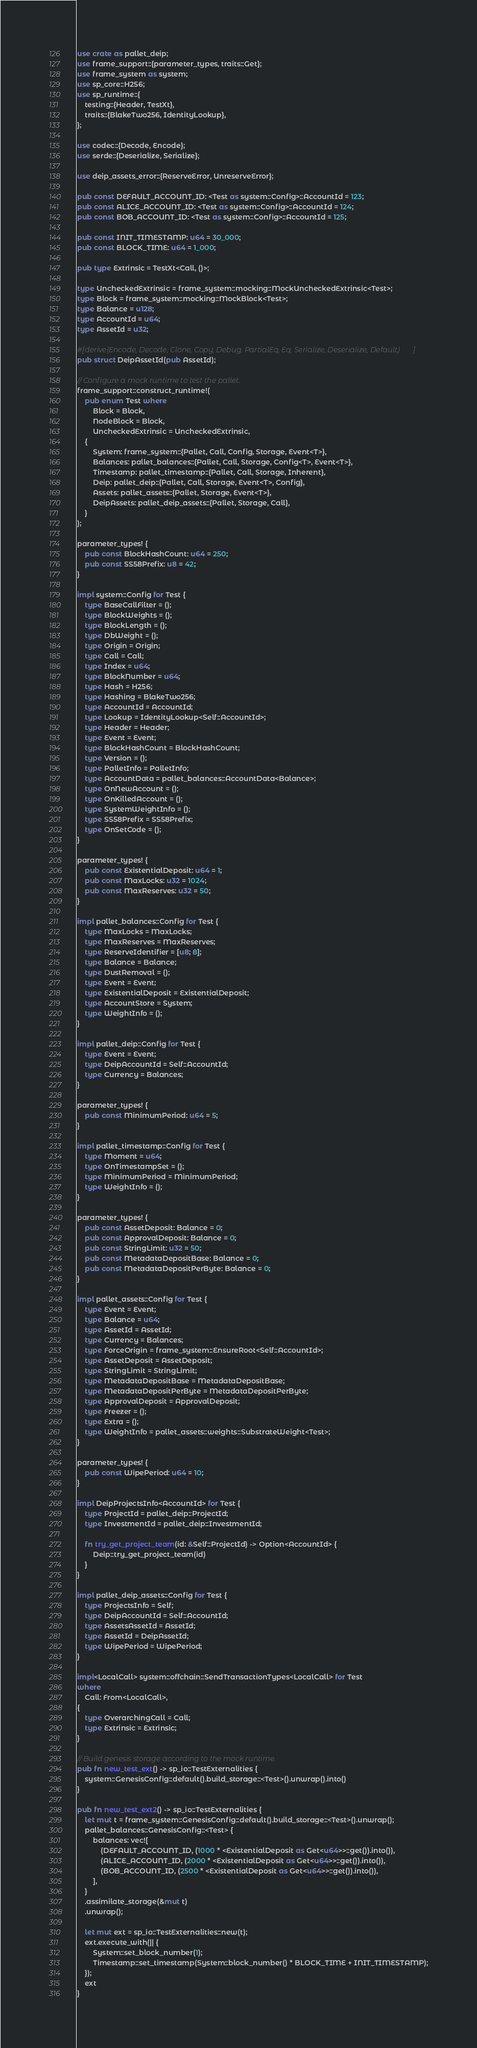Convert code to text. <code><loc_0><loc_0><loc_500><loc_500><_Rust_>use crate as pallet_deip;
use frame_support::{parameter_types, traits::Get};
use frame_system as system;
use sp_core::H256;
use sp_runtime::{
    testing::{Header, TestXt},
    traits::{BlakeTwo256, IdentityLookup},
};

use codec::{Decode, Encode};
use serde::{Deserialize, Serialize};

use deip_assets_error::{ReserveError, UnreserveError};

pub const DEFAULT_ACCOUNT_ID: <Test as system::Config>::AccountId = 123;
pub const ALICE_ACCOUNT_ID: <Test as system::Config>::AccountId = 124;
pub const BOB_ACCOUNT_ID: <Test as system::Config>::AccountId = 125;

pub const INIT_TIMESTAMP: u64 = 30_000;
pub const BLOCK_TIME: u64 = 1_000;

pub type Extrinsic = TestXt<Call, ()>;

type UncheckedExtrinsic = frame_system::mocking::MockUncheckedExtrinsic<Test>;
type Block = frame_system::mocking::MockBlock<Test>;
type Balance = u128;
type AccountId = u64;
type AssetId = u32;

#[derive(Encode, Decode, Clone, Copy, Debug, PartialEq, Eq, Serialize, Deserialize, Default)]
pub struct DeipAssetId(pub AssetId);

// Configure a mock runtime to test the pallet.
frame_support::construct_runtime!(
    pub enum Test where
        Block = Block,
        NodeBlock = Block,
        UncheckedExtrinsic = UncheckedExtrinsic,
    {
        System: frame_system::{Pallet, Call, Config, Storage, Event<T>},
        Balances: pallet_balances::{Pallet, Call, Storage, Config<T>, Event<T>},
        Timestamp: pallet_timestamp::{Pallet, Call, Storage, Inherent},
        Deip: pallet_deip::{Pallet, Call, Storage, Event<T>, Config},
        Assets: pallet_assets::{Pallet, Storage, Event<T>},
        DeipAssets: pallet_deip_assets::{Pallet, Storage, Call},
    }
);

parameter_types! {
    pub const BlockHashCount: u64 = 250;
    pub const SS58Prefix: u8 = 42;
}

impl system::Config for Test {
    type BaseCallFilter = ();
    type BlockWeights = ();
    type BlockLength = ();
    type DbWeight = ();
    type Origin = Origin;
    type Call = Call;
    type Index = u64;
    type BlockNumber = u64;
    type Hash = H256;
    type Hashing = BlakeTwo256;
    type AccountId = AccountId;
    type Lookup = IdentityLookup<Self::AccountId>;
    type Header = Header;
    type Event = Event;
    type BlockHashCount = BlockHashCount;
    type Version = ();
    type PalletInfo = PalletInfo;
    type AccountData = pallet_balances::AccountData<Balance>;
    type OnNewAccount = ();
    type OnKilledAccount = ();
    type SystemWeightInfo = ();
    type SS58Prefix = SS58Prefix;
    type OnSetCode = ();
}

parameter_types! {
    pub const ExistentialDeposit: u64 = 1;
    pub const MaxLocks: u32 = 1024;
    pub const MaxReserves: u32 = 50;
}

impl pallet_balances::Config for Test {
    type MaxLocks = MaxLocks;
    type MaxReserves = MaxReserves;
    type ReserveIdentifier = [u8; 8];
    type Balance = Balance;
    type DustRemoval = ();
    type Event = Event;
    type ExistentialDeposit = ExistentialDeposit;
    type AccountStore = System;
    type WeightInfo = ();
}

impl pallet_deip::Config for Test {
    type Event = Event;
    type DeipAccountId = Self::AccountId;
    type Currency = Balances;
}

parameter_types! {
    pub const MinimumPeriod: u64 = 5;
}

impl pallet_timestamp::Config for Test {
    type Moment = u64;
    type OnTimestampSet = ();
    type MinimumPeriod = MinimumPeriod;
    type WeightInfo = ();
}

parameter_types! {
    pub const AssetDeposit: Balance = 0;
    pub const ApprovalDeposit: Balance = 0;
    pub const StringLimit: u32 = 50;
    pub const MetadataDepositBase: Balance = 0;
    pub const MetadataDepositPerByte: Balance = 0;
}

impl pallet_assets::Config for Test {
    type Event = Event;
    type Balance = u64;
    type AssetId = AssetId;
    type Currency = Balances;
    type ForceOrigin = frame_system::EnsureRoot<Self::AccountId>;
    type AssetDeposit = AssetDeposit;
    type StringLimit = StringLimit;
    type MetadataDepositBase = MetadataDepositBase;
    type MetadataDepositPerByte = MetadataDepositPerByte;
    type ApprovalDeposit = ApprovalDeposit;
    type Freezer = ();
    type Extra = ();
    type WeightInfo = pallet_assets::weights::SubstrateWeight<Test>;
}

parameter_types! {
    pub const WipePeriod: u64 = 10;
}

impl DeipProjectsInfo<AccountId> for Test {
    type ProjectId = pallet_deip::ProjectId;
    type InvestmentId = pallet_deip::InvestmentId;

    fn try_get_project_team(id: &Self::ProjectId) -> Option<AccountId> {
        Deip::try_get_project_team(id)
    }
}

impl pallet_deip_assets::Config for Test {
    type ProjectsInfo = Self;
    type DeipAccountId = Self::AccountId;
    type AssetsAssetId = AssetId;
    type AssetId = DeipAssetId;
    type WipePeriod = WipePeriod;
}

impl<LocalCall> system::offchain::SendTransactionTypes<LocalCall> for Test
where
    Call: From<LocalCall>,
{
    type OverarchingCall = Call;
    type Extrinsic = Extrinsic;
}

// Build genesis storage according to the mock runtime.
pub fn new_test_ext() -> sp_io::TestExternalities {
    system::GenesisConfig::default().build_storage::<Test>().unwrap().into()
}

pub fn new_test_ext2() -> sp_io::TestExternalities {
    let mut t = frame_system::GenesisConfig::default().build_storage::<Test>().unwrap();
    pallet_balances::GenesisConfig::<Test> {
        balances: vec![
            (DEFAULT_ACCOUNT_ID, (1000 * <ExistentialDeposit as Get<u64>>::get()).into()),
            (ALICE_ACCOUNT_ID, (2000 * <ExistentialDeposit as Get<u64>>::get()).into()),
            (BOB_ACCOUNT_ID, (2500 * <ExistentialDeposit as Get<u64>>::get()).into()),
        ],
    }
    .assimilate_storage(&mut t)
    .unwrap();

    let mut ext = sp_io::TestExternalities::new(t);
    ext.execute_with(|| {
        System::set_block_number(1);
        Timestamp::set_timestamp(System::block_number() * BLOCK_TIME + INIT_TIMESTAMP);
    });
    ext
}
</code> 